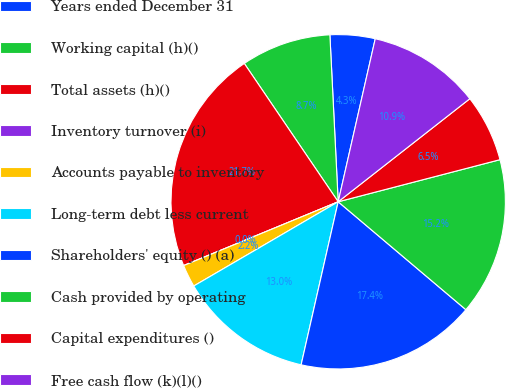Convert chart to OTSL. <chart><loc_0><loc_0><loc_500><loc_500><pie_chart><fcel>Years ended December 31<fcel>Working capital (h)()<fcel>Total assets (h)()<fcel>Inventory turnover (i)<fcel>Accounts payable to inventory<fcel>Long-term debt less current<fcel>Shareholders' equity () (a)<fcel>Cash provided by operating<fcel>Capital expenditures ()<fcel>Free cash flow (k)(l)()<nl><fcel>4.35%<fcel>8.7%<fcel>21.74%<fcel>0.0%<fcel>2.17%<fcel>13.04%<fcel>17.39%<fcel>15.22%<fcel>6.52%<fcel>10.87%<nl></chart> 